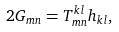Convert formula to latex. <formula><loc_0><loc_0><loc_500><loc_500>2 G _ { m n } = T _ { m n } ^ { k l } h _ { k l } ,</formula> 